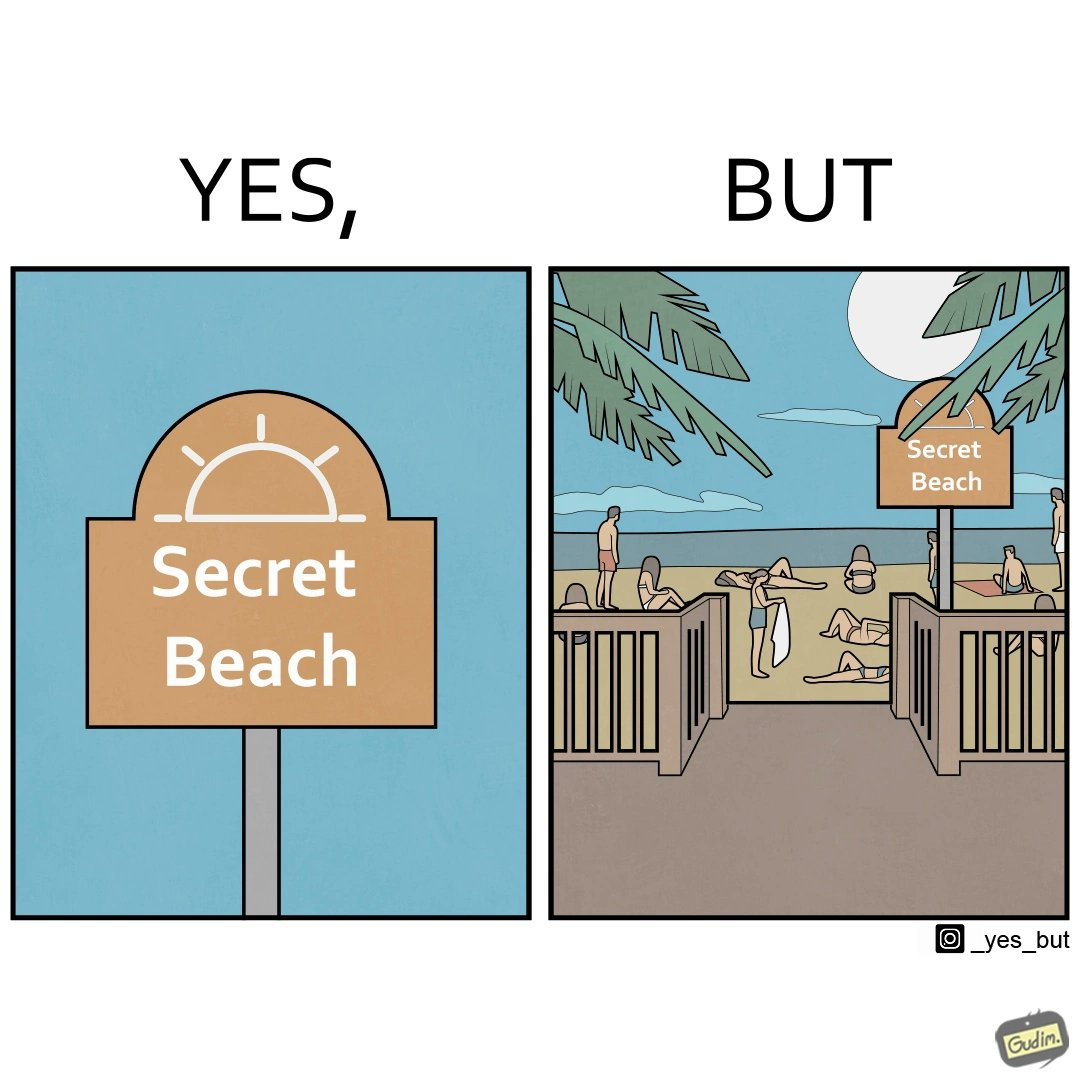Describe the content of this image. The image is ironical, as people can be seen in the beach, and is clearly not a secret, while the board at the entrance has "Secret Beach" written on it. 